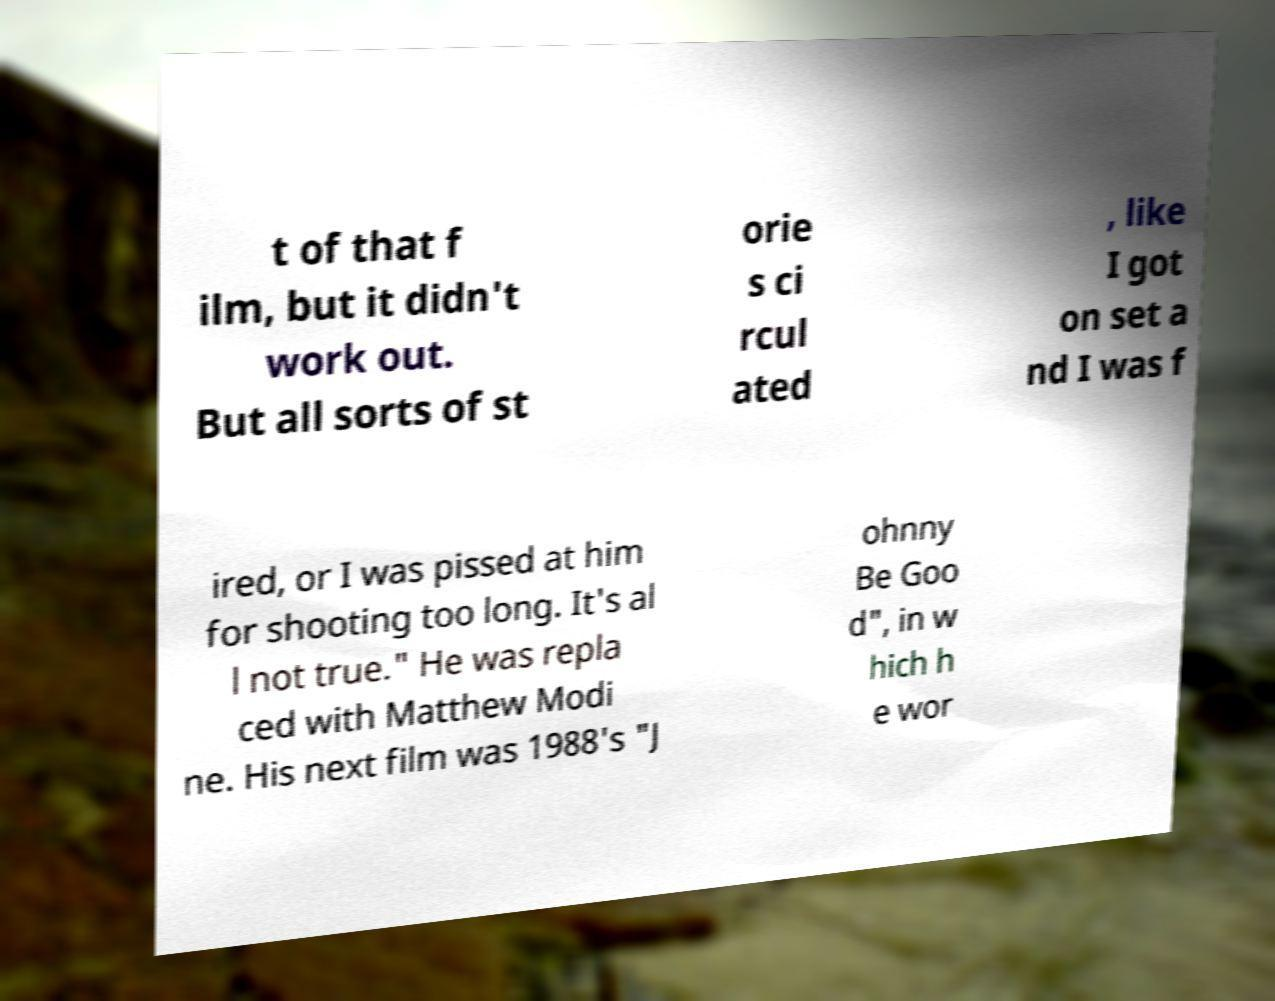What messages or text are displayed in this image? I need them in a readable, typed format. t of that f ilm, but it didn't work out. But all sorts of st orie s ci rcul ated , like I got on set a nd I was f ired, or I was pissed at him for shooting too long. It's al l not true." He was repla ced with Matthew Modi ne. His next film was 1988's "J ohnny Be Goo d", in w hich h e wor 